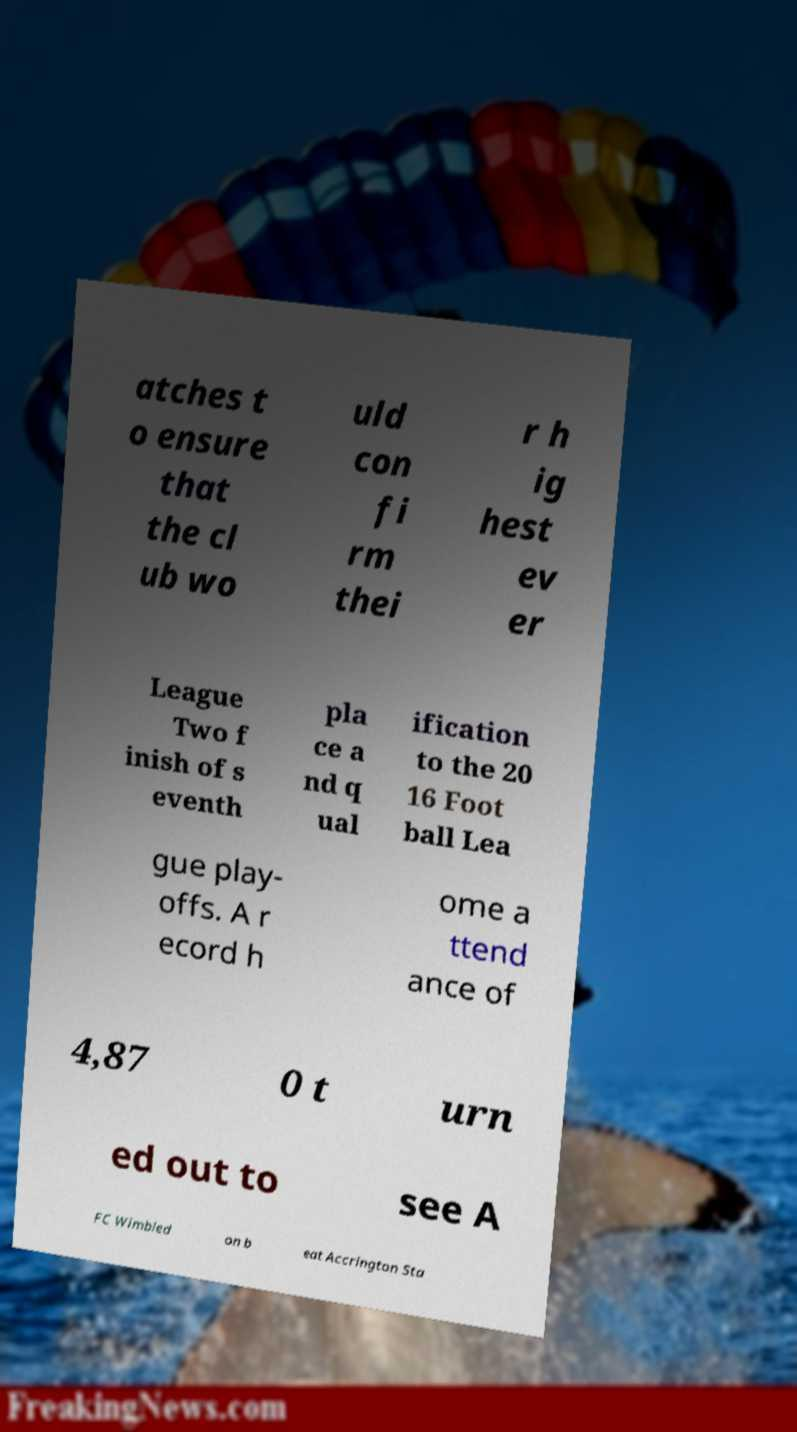What messages or text are displayed in this image? I need them in a readable, typed format. atches t o ensure that the cl ub wo uld con fi rm thei r h ig hest ev er League Two f inish of s eventh pla ce a nd q ual ification to the 20 16 Foot ball Lea gue play- offs. A r ecord h ome a ttend ance of 4,87 0 t urn ed out to see A FC Wimbled on b eat Accrington Sta 